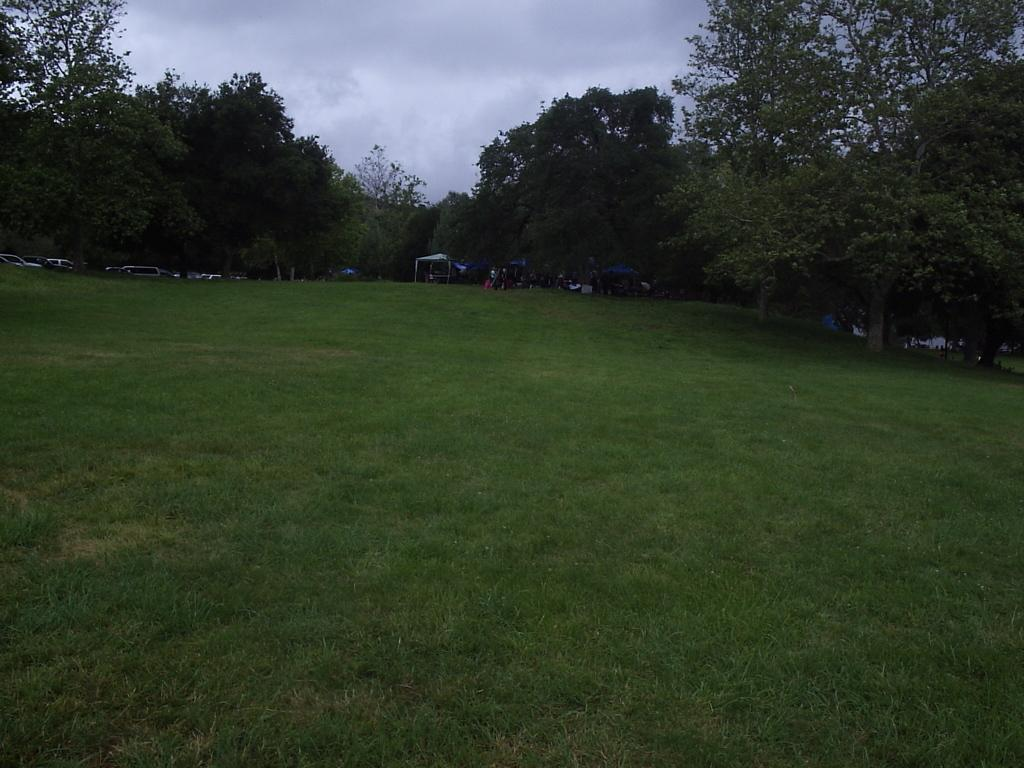What type of vegetation is on the ground in the image? There is grass on the ground in the image. What can be seen in the background of the image? There are trees in the background of the image. What else is visible in the image besides the grass and trees? There are vehicles in the image. What is visible above the trees and vehicles in the image? The sky is visible in the image. What can be observed in the sky? Clouds are present in the sky. What type of cheese is being held by the hands in the image? There are no hands or cheese present in the image. What fact can be learned from the image? The image itself does not convey any specific fact; it simply shows grass, trees, vehicles, and a sky with clouds. 